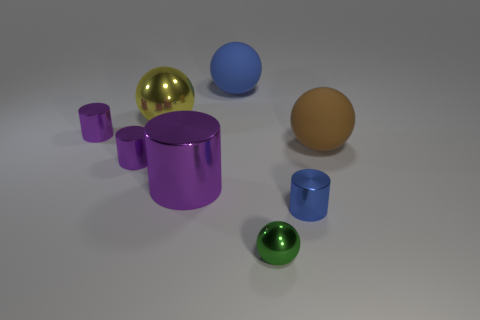How many other things are there of the same material as the tiny ball?
Provide a succinct answer. 5. Does the green ball have the same material as the brown thing?
Provide a succinct answer. No. Are there the same number of brown things behind the big purple thing and purple cylinders behind the large brown object?
Make the answer very short. Yes. How many large yellow shiny spheres are there?
Provide a short and direct response. 1. Is the number of big brown things behind the yellow metallic ball greater than the number of large yellow objects?
Offer a terse response. No. What material is the thing to the right of the small blue thing?
Make the answer very short. Rubber. What is the color of the small object that is the same shape as the large brown thing?
Make the answer very short. Green. What number of big metallic spheres have the same color as the small shiny sphere?
Your response must be concise. 0. There is a metallic sphere that is right of the large blue thing; is its size the same as the blue metal cylinder on the right side of the yellow ball?
Keep it short and to the point. Yes. Does the brown thing have the same size as the blue object that is right of the green thing?
Keep it short and to the point. No. 